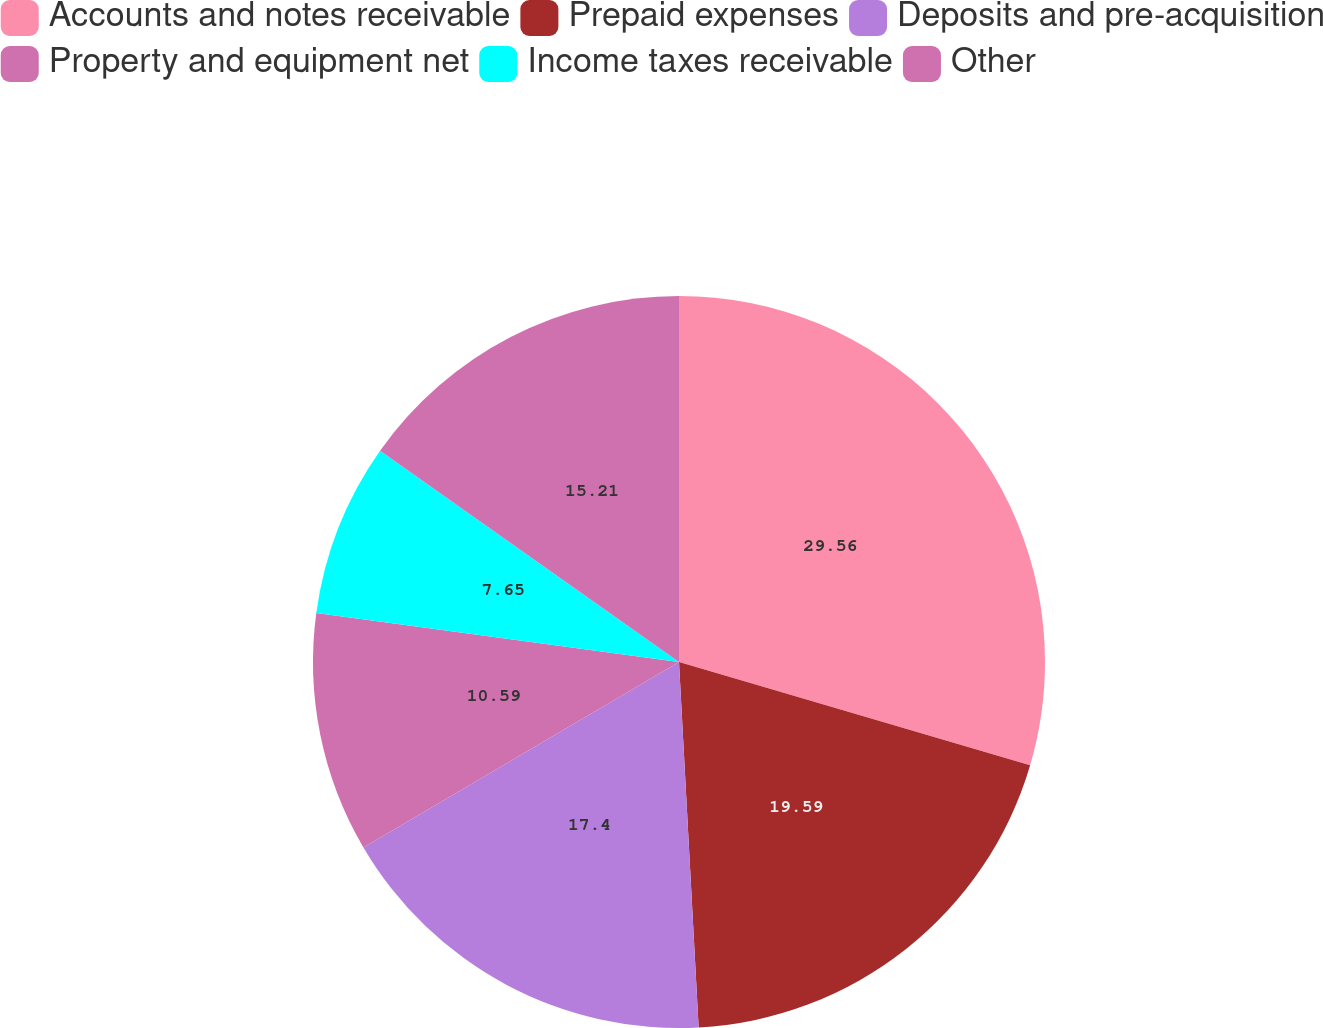<chart> <loc_0><loc_0><loc_500><loc_500><pie_chart><fcel>Accounts and notes receivable<fcel>Prepaid expenses<fcel>Deposits and pre-acquisition<fcel>Property and equipment net<fcel>Income taxes receivable<fcel>Other<nl><fcel>29.55%<fcel>19.59%<fcel>17.4%<fcel>10.59%<fcel>7.65%<fcel>15.21%<nl></chart> 